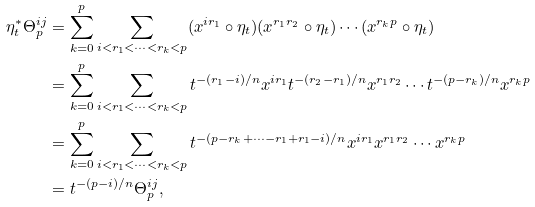Convert formula to latex. <formula><loc_0><loc_0><loc_500><loc_500>\eta _ { t } ^ { * } \Theta _ { p } ^ { i j } & = \sum _ { k = 0 } ^ { p } \sum _ { i < r _ { 1 } < \cdots < r _ { k } < p } ( x ^ { i r _ { 1 } } \circ \eta _ { t } ) ( x ^ { r _ { 1 } r _ { 2 } } \circ \eta _ { t } ) \cdots ( x ^ { r _ { k } p } \circ \eta _ { t } ) \\ & = \sum _ { k = 0 } ^ { p } \sum _ { i < r _ { 1 } < \cdots < r _ { k } < p } t ^ { - ( r _ { 1 } - i ) / n } x ^ { i r _ { 1 } } t ^ { - ( r _ { 2 } - r _ { 1 } ) / n } x ^ { r _ { 1 } r _ { 2 } } \cdots t ^ { - ( p - r _ { k } ) / n } x ^ { r _ { k } p } \\ & = \sum _ { k = 0 } ^ { p } \sum _ { i < r _ { 1 } < \cdots < r _ { k } < p } t ^ { - ( p - r _ { k } + \cdots - r _ { 1 } + r _ { 1 } - i ) / n } x ^ { i r _ { 1 } } x ^ { r _ { 1 } r _ { 2 } } \cdots x ^ { r _ { k } p } \\ & = t ^ { - ( p - i ) / n } \Theta _ { p } ^ { i j } ,</formula> 